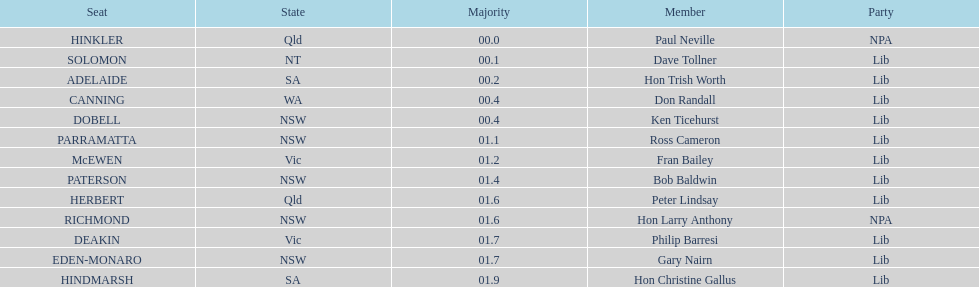Reveal the total of seats from nsw? 5. 